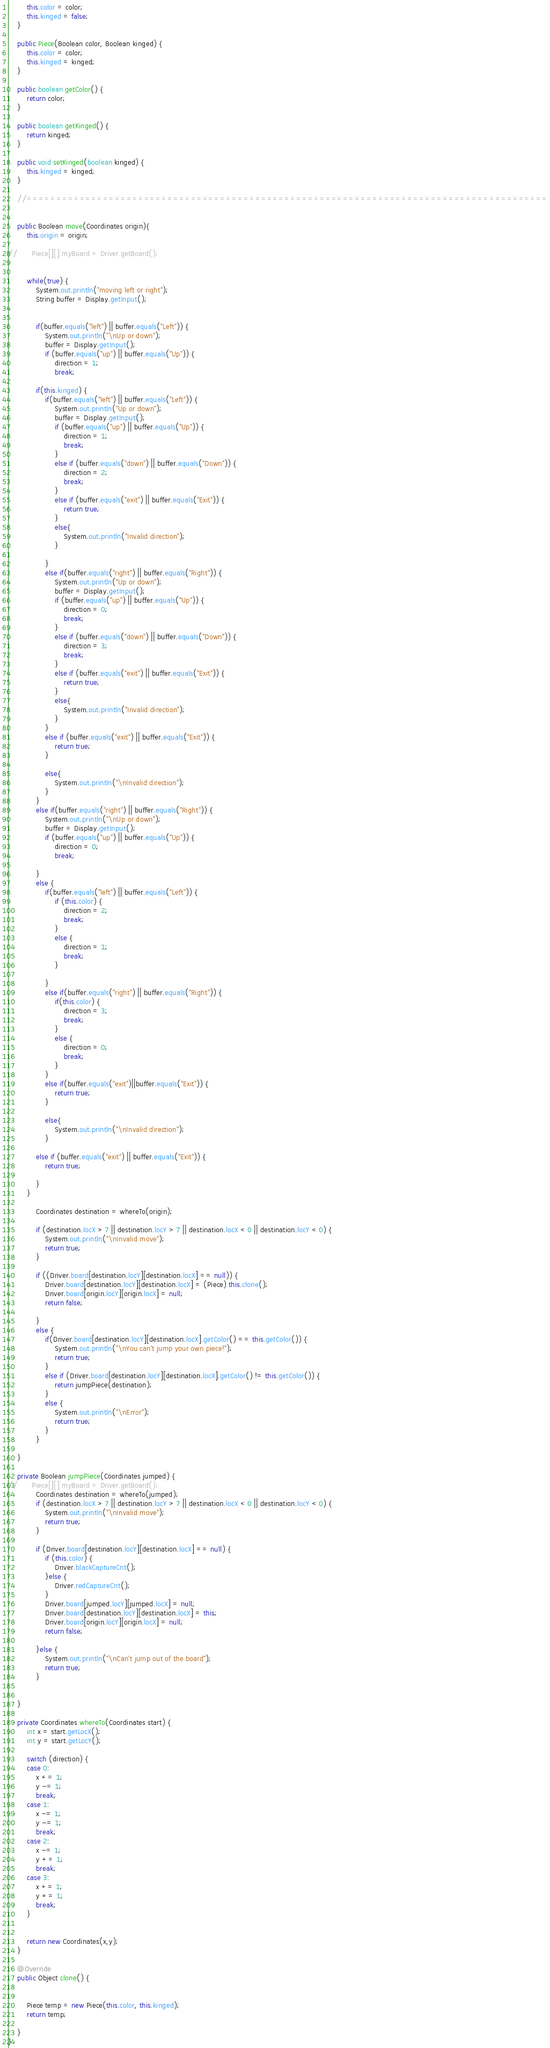<code> <loc_0><loc_0><loc_500><loc_500><_Java_>		this.color = color;
		this.kinged = false;
	}
	
	public Piece(Boolean color, Boolean kinged) {
		this.color = color;
		this.kinged = kinged;
	}
	
	public boolean getColor() {
		return color;
	}
	
	public boolean getKinged() {
		return kinged;
	}
	
	public void setKinged(boolean kinged) {
		this.kinged = kinged;
	}

	//=========================================================================================
	

	public Boolean move(Coordinates origin){
		this.origin = origin;
		
//		Piece[][] myBoard = Driver.getBoard();
		
		
		while(true) {
			System.out.println("moving left or right");
			String buffer = Display.getInput();

			
			if(buffer.equals("left") || buffer.equals("Left")) {
				System.out.println("\nUp or down");
				buffer = Display.getInput();
				if (buffer.equals("up") || buffer.equals("Up")) {
					direction = 1;
					break;

			if(this.kinged) {
				if(buffer.equals("left") || buffer.equals("Left")) {
					System.out.println("Up or down");
					buffer = Display.getInput();
					if (buffer.equals("up") || buffer.equals("Up")) {
						direction = 1;
						break;
					}
					else if (buffer.equals("down") || buffer.equals("Down")) {
						direction = 2;
						break;
					}
					else if (buffer.equals("exit") || buffer.equals("Exit")) {
						return true;
					}
					else{
						System.out.println("Invalid direction");
					}

				}
				else if(buffer.equals("right") || buffer.equals("Right")) {
					System.out.println("Up or down");
					buffer = Display.getInput();
					if (buffer.equals("up") || buffer.equals("Up")) {
						direction = 0;
						break;
					}
					else if (buffer.equals("down") || buffer.equals("Down")) {
						direction = 3;
						break;
					}
					else if (buffer.equals("exit") || buffer.equals("Exit")) {
						return true;
					}
					else{
						System.out.println("Invalid direction");
					}
				}
				else if (buffer.equals("exit") || buffer.equals("Exit")) {
					return true;
				}

				else{
					System.out.println("\nInvalid direction");
				}
			}
			else if(buffer.equals("right") || buffer.equals("Right")) {
				System.out.println("\nUp or down");
				buffer = Display.getInput();
				if (buffer.equals("up") || buffer.equals("Up")) {
					direction = 0;
					break;

			}
			else {
				if(buffer.equals("left") || buffer.equals("Left")) {
					if (this.color) {
						direction = 2;
						break;
					}
					else {
						direction = 1;
						break;
					}

				}
				else if(buffer.equals("right") || buffer.equals("Right")) {
					if(this.color) {
						direction = 3;
						break;
					}
					else {
						direction = 0;
						break;
					}
				}
				else if(buffer.equals("exit")||buffer.equals("Exit")) {
					return true;
				}

				else{
					System.out.println("\nInvalid direction");
				}
			
			else if (buffer.equals("exit") || buffer.equals("Exit")) {
				return true;

			}
		}	
			
			Coordinates destination = whereTo(origin);
			
			if (destination.locX > 7 || destination.locY > 7 || destination.locX < 0 || destination.locY < 0) {
				System.out.println("\nInvalid move");
				return true;
			}
			
			if ((Driver.board[destination.locY][destination.locX] == null)) {
				Driver.board[destination.locY][destination.locX] = (Piece) this.clone();
				Driver.board[origin.locY][origin.locX] = null;
				return false;
				
			}
			else {
				if(Driver.board[destination.locY][destination.locX].getColor() == this.getColor()) {
					System.out.println("\nYou can't jump your own piece!");
					return true;
				}
				else if (Driver.board[destination.locY][destination.locX].getColor() != this.getColor()) {
					return jumpPiece(destination);
				}
				else {
					System.out.println("\nError");
					return true;
				}
			}
				
	}
	
	private Boolean jumpPiece(Coordinates jumped) {
//		Piece[][] myBoard = Driver.getBoard();
			Coordinates destination = whereTo(jumped);
			if (destination.locX > 7 || destination.locY > 7 || destination.locX < 0 || destination.locY < 0) {
				System.out.println("\nInvalid move");
				return true;
			}
			
			if (Driver.board[destination.locY][destination.locX] == null) {
				if (this.color) {
					Driver.blackCaptureCnt();
				}else {
					Driver.redCaptureCnt();
				}
				Driver.board[jumped.locY][jumped.locX] = null;
				Driver.board[destination.locY][destination.locX] = this;
				Driver.board[origin.locY][origin.locX] = null;
				return false;
				
			}else {
				System.out.println("\nCan't jump out of the board");
				return true;
			}
			
			
	}

	private Coordinates whereTo(Coordinates start) {
		int x = start.getLocX();
		int y = start.getLocY();
		
		switch (direction) {
		case 0: 
			x += 1;
			y -= 1;
			break;
		case 1: 
			x -= 1; 
			y -= 1;
			break;
		case 2: 
			x -= 1; 
			y += 1;
			break;
		case 3:
			x += 1;
			y += 1;
			break;
		}
		
			
		return new Coordinates(x,y);
	}
	
	@Override
	public Object clone() {
		
		
		Piece temp = new Piece(this.color, this.kinged);
		return temp;
		
	}
}</code> 